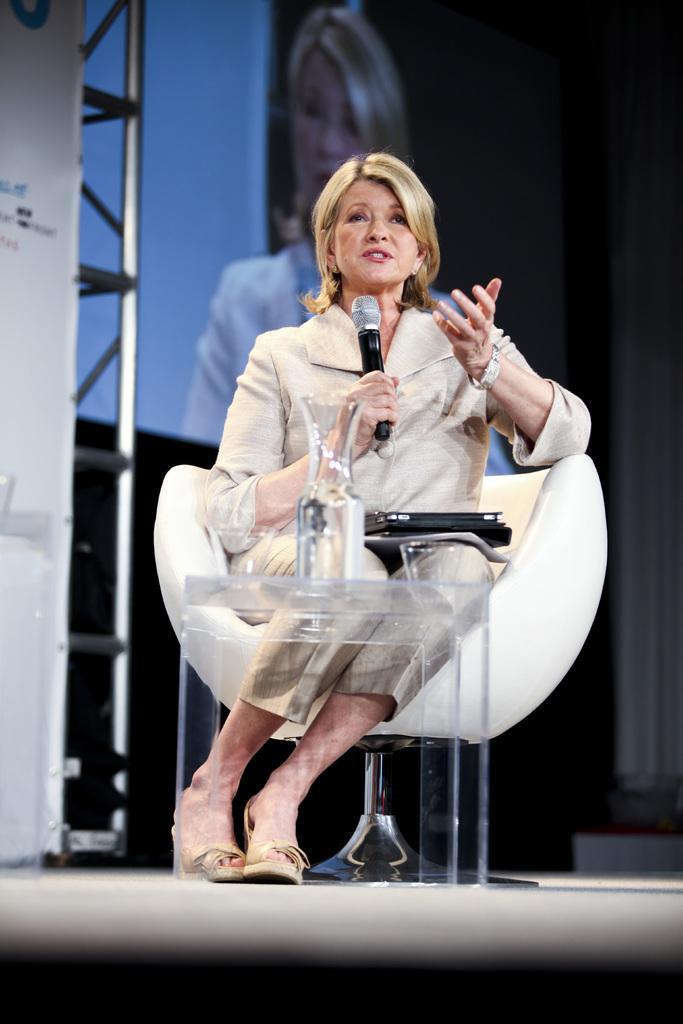Describe this image in one or two sentences. In the middle of the image we can see a woman, she is sitting and she is holding a microphone, in front of her we can see a vase on the table, in the background we can see few metal rods and a screen. 